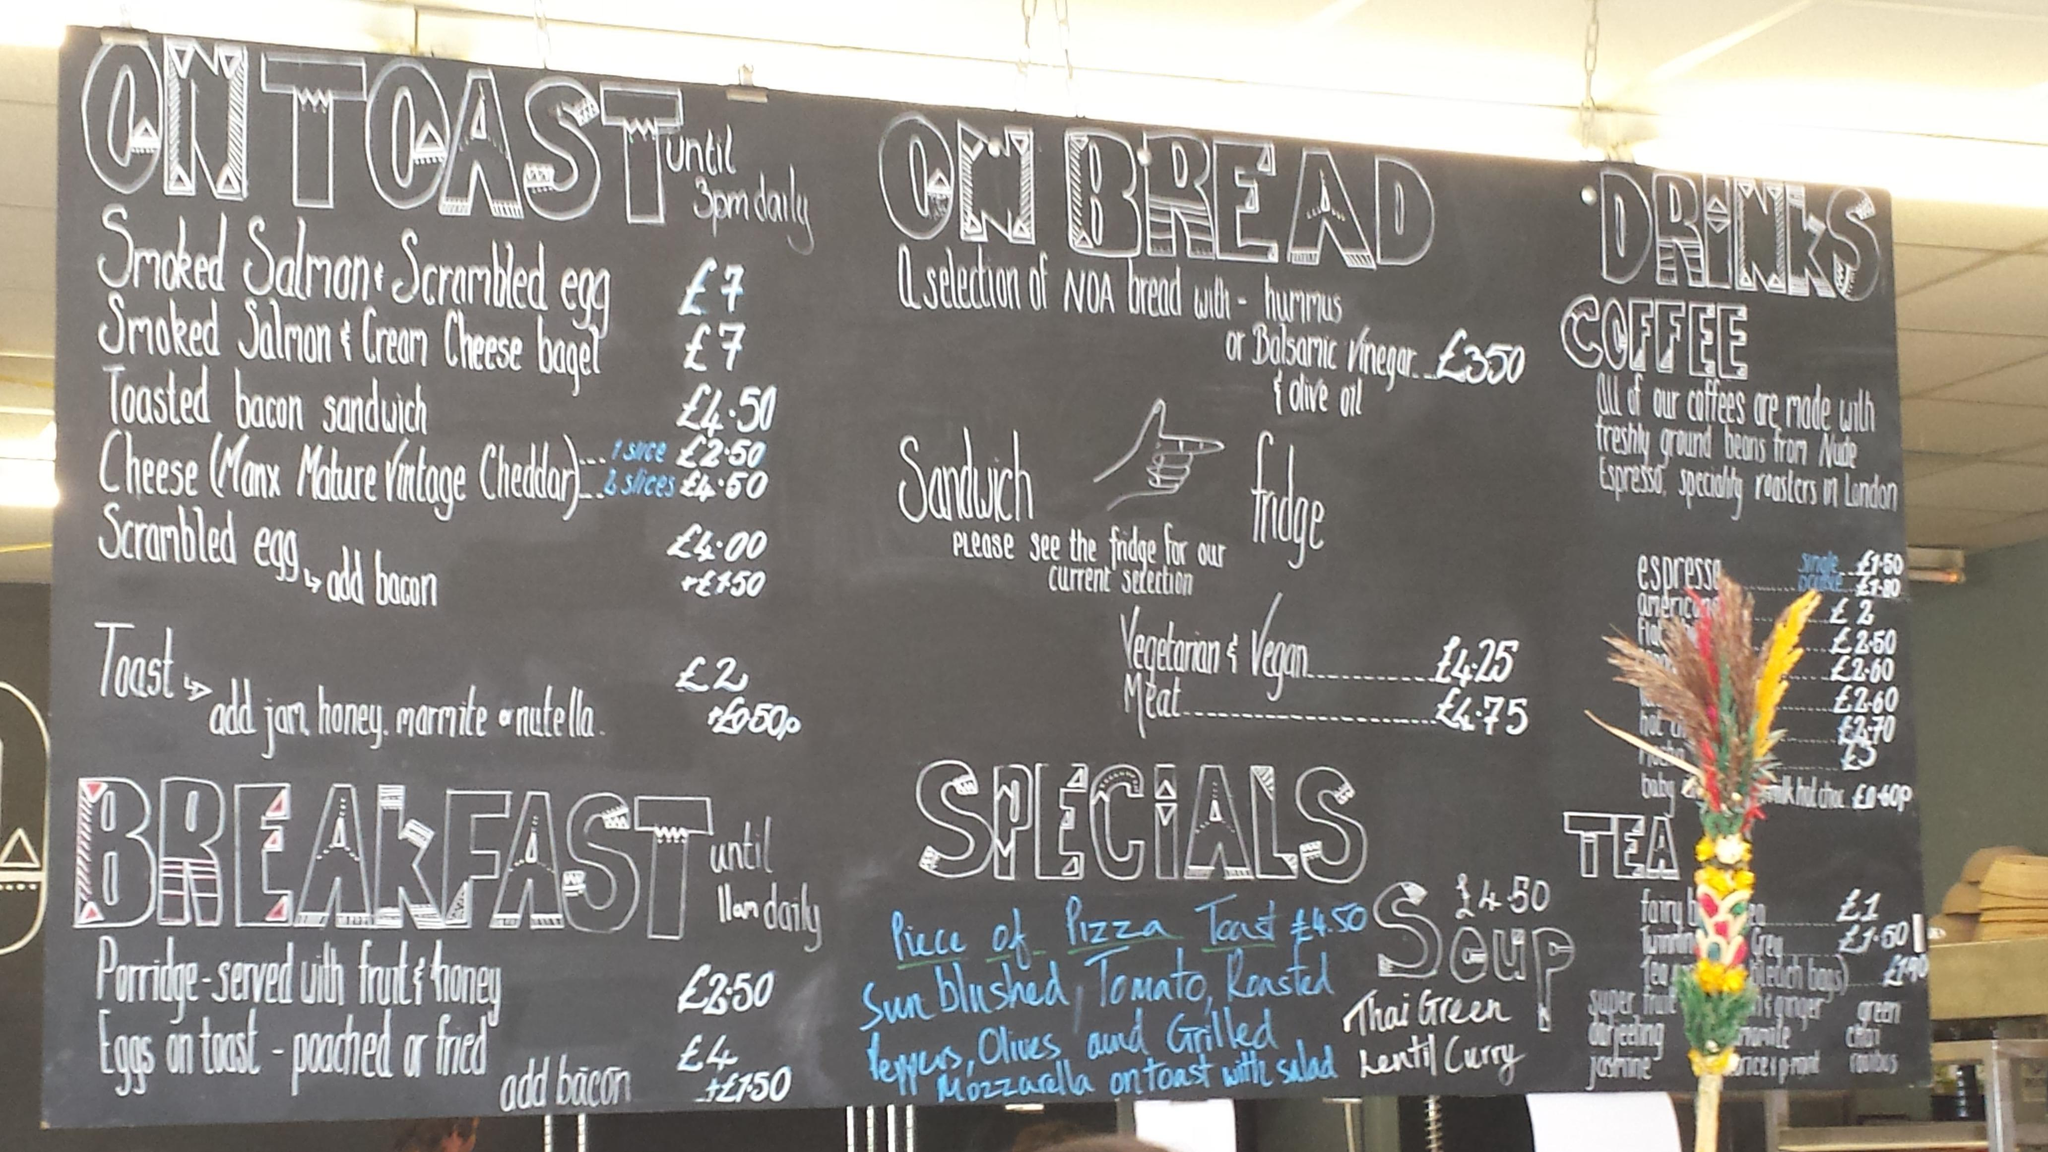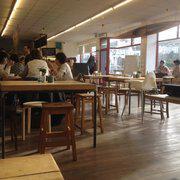The first image is the image on the left, the second image is the image on the right. Analyze the images presented: Is the assertion "There is at least one chalkboard in the left image." valid? Answer yes or no. Yes. The first image is the image on the left, the second image is the image on the right. Considering the images on both sides, is "there are wooden tables and chairs on a wooden floor" valid? Answer yes or no. Yes. 